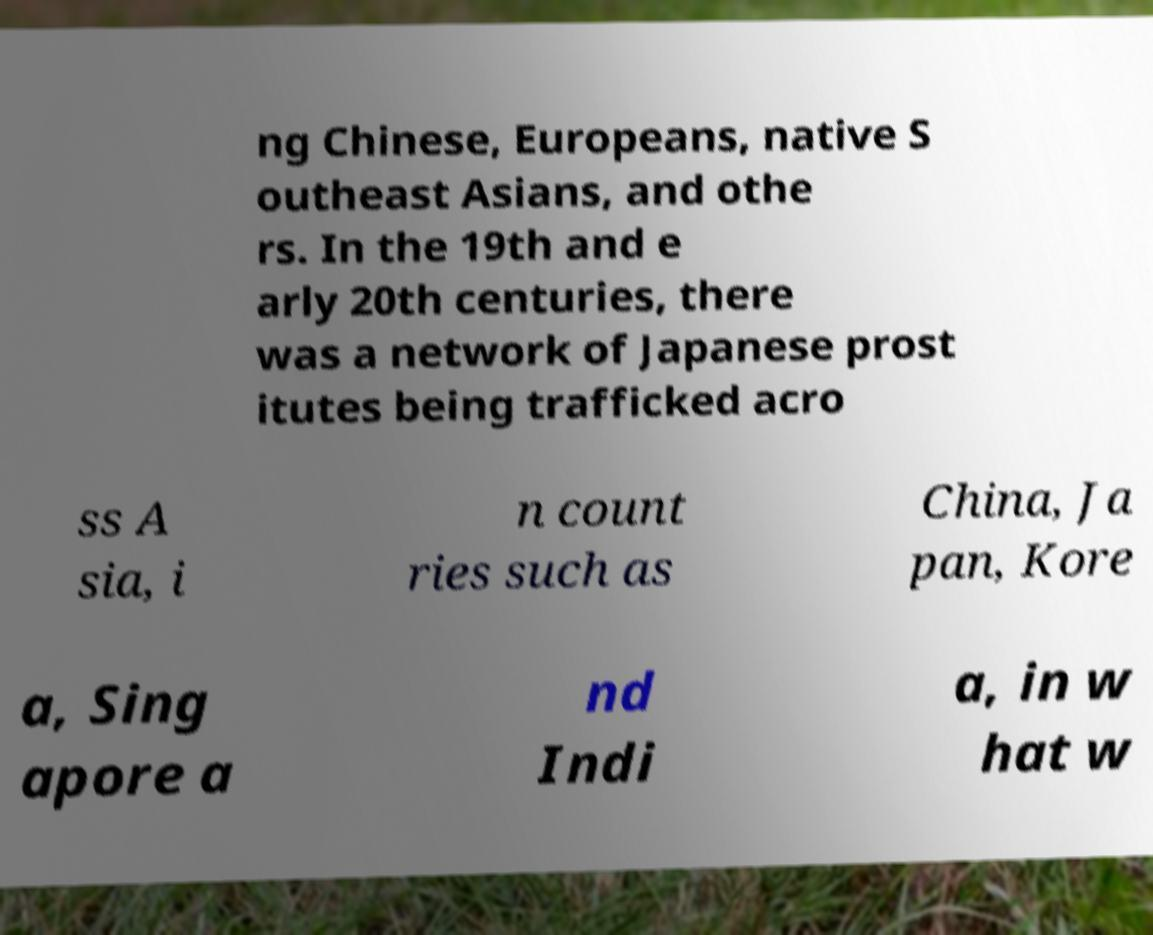Can you read and provide the text displayed in the image?This photo seems to have some interesting text. Can you extract and type it out for me? ng Chinese, Europeans, native S outheast Asians, and othe rs. In the 19th and e arly 20th centuries, there was a network of Japanese prost itutes being trafficked acro ss A sia, i n count ries such as China, Ja pan, Kore a, Sing apore a nd Indi a, in w hat w 